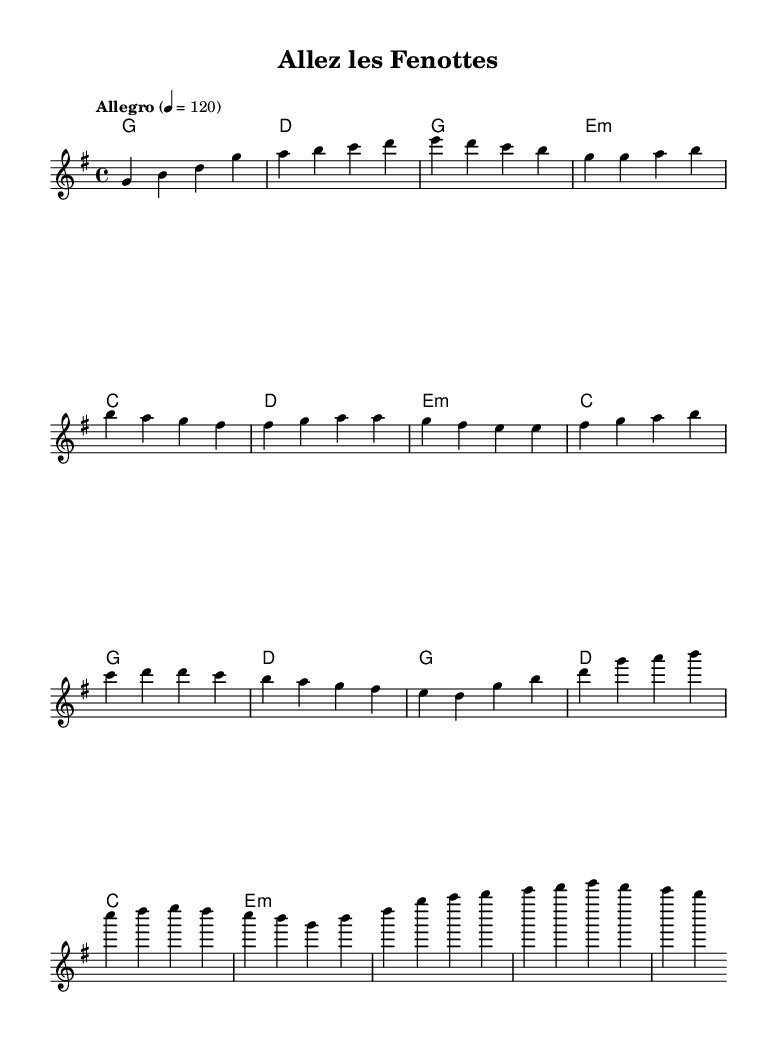What is the key signature of the music? The key signature is G major, which has one sharp (F#). This is indicated at the beginning of the sheet music.
Answer: G major What is the time signature of the music? The time signature is 4/4, which means there are four beats per measure and a quarter note receives one beat. This is also indicated at the start of the score.
Answer: 4/4 What is the tempo of the piece? The tempo is marked "Allegro" with a metronome marking of 120 beats per minute, suggesting a fast tempo. This is noted in the header of the score.
Answer: Allegro How many measures are in the chorus section? The chorus section consists of four measures. By reviewing the notated measures in the chorus part, you can count them directly.
Answer: Four measures What is the final chord in the piece? The final chord in the music is E minor, which is found at the end of the score within the harmonies section. It indicates the tonality at the conclusion.
Answer: E minor What comes after the pre-chorus in the structure of the song? After the pre-chorus, the chorus follows, as indicated by the structure established in the notation throughout the sheet music.
Answer: Chorus Which part of the song has the ascending melody pattern? The pre-chorus features an ascending melody pattern, which can be identified by the rising pitches from E to D in the melody line.
Answer: Pre-chorus 